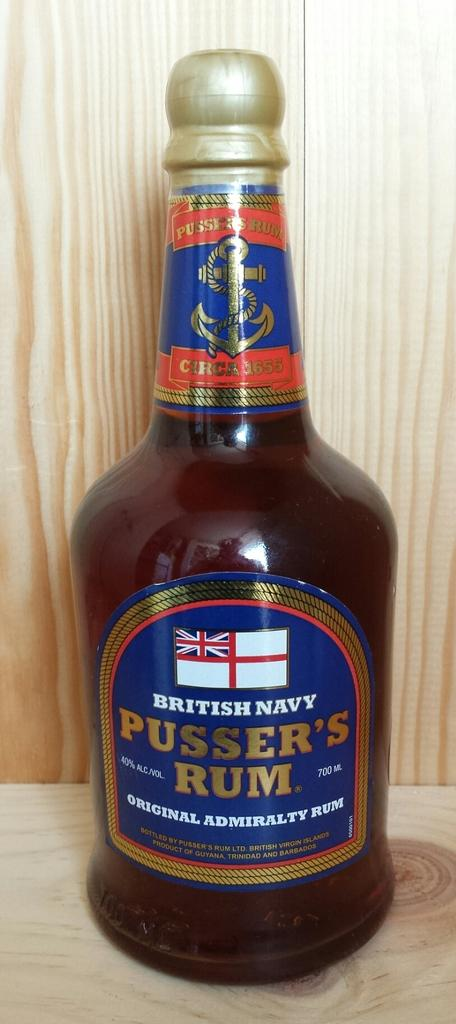<image>
Share a concise interpretation of the image provided. bottle of british navy pusser's rum original admiraly rum 